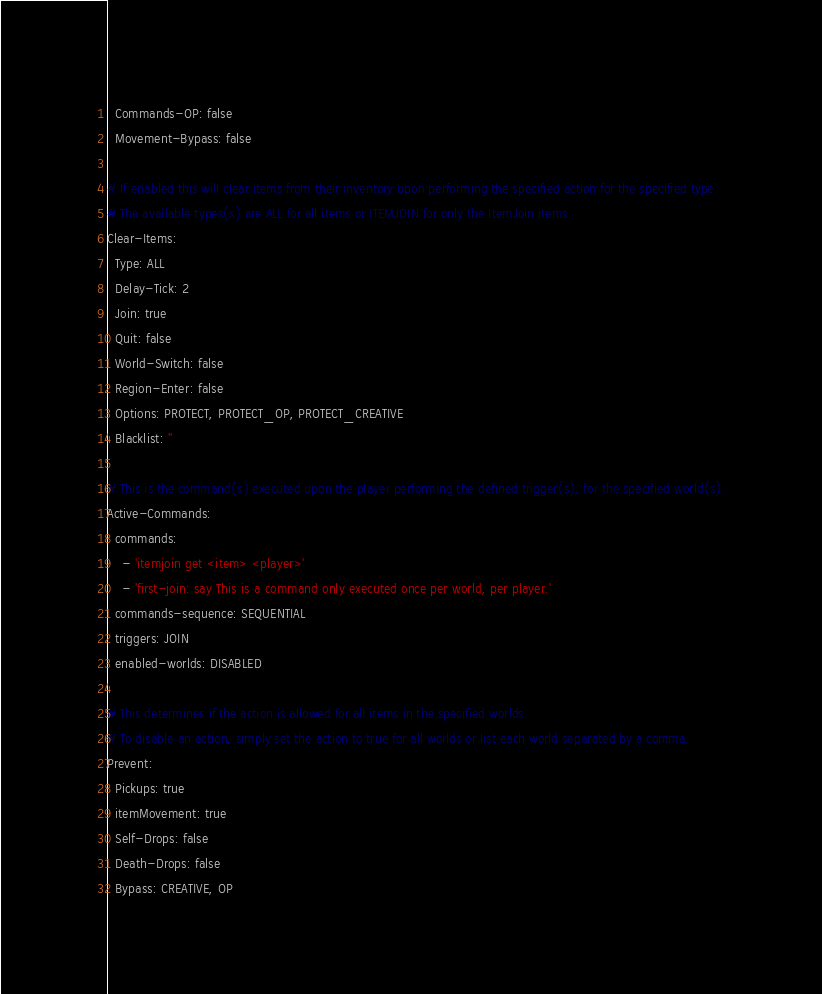Convert code to text. <code><loc_0><loc_0><loc_500><loc_500><_YAML_>  Commands-OP: false
  Movement-Bypass: false

# If enabled this will clear items from their inventory upon performing the specified action for the specified type.
# The available types(s) are ALL for all items or ITEMJOIN for only the ItemJoin items.
Clear-Items:
  Type: ALL
  Delay-Tick: 2
  Join: true
  Quit: false
  World-Switch: false
  Region-Enter: false
  Options: PROTECT, PROTECT_OP, PROTECT_CREATIVE
  Blacklist: ''

# This is the command(s) executed upon the player performing the defined trigger(s), for the specified world(s).
Active-Commands:
  commands:
    - 'itemjoin get <item> <player>'
    - 'first-join: say This is a command only executed once per world, per player.'
  commands-sequence: SEQUENTIAL
  triggers: JOIN
  enabled-worlds: DISABLED

# This determines if the action is allowed for all items in the specified worlds.
# To disable an action, simply set the action to true for all worlds or list each world separated by a comma.
Prevent:
  Pickups: true
  itemMovement: true
  Self-Drops: false
  Death-Drops: false
  Bypass: CREATIVE, OP</code> 